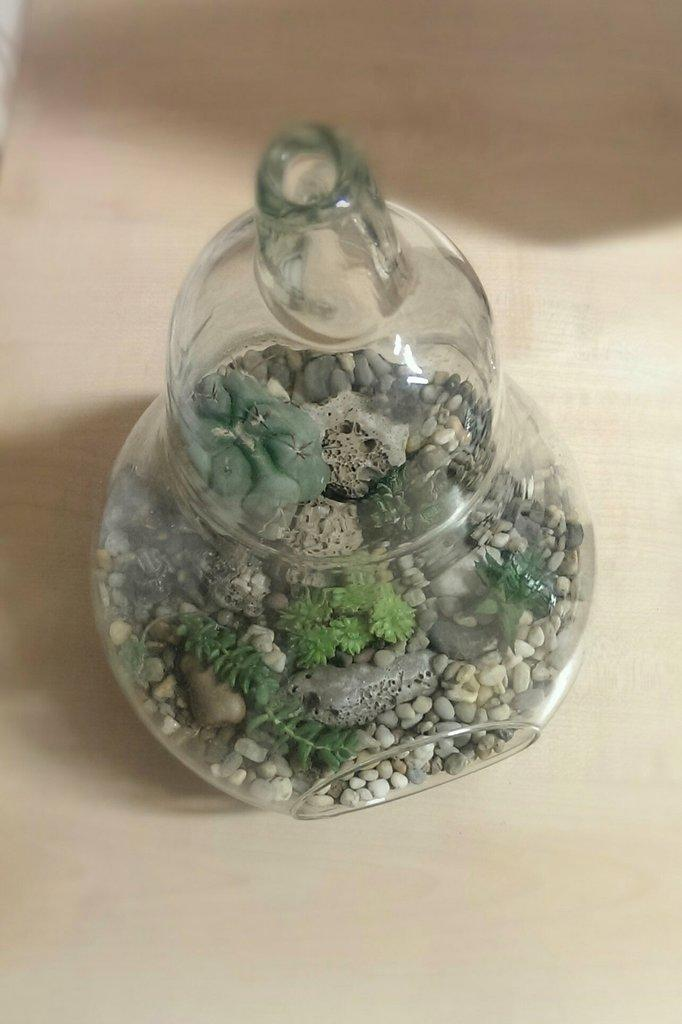What object is visible in the image? There is a glass jar in the image. What is inside the glass jar? There are stones and plastic structures inside the glass jar. Where is the image likely taken? The image appears to be on a table. How many hands are visible in the image? There are no hands visible in the image; it only shows a glass jar with stones and plastic structures inside. 